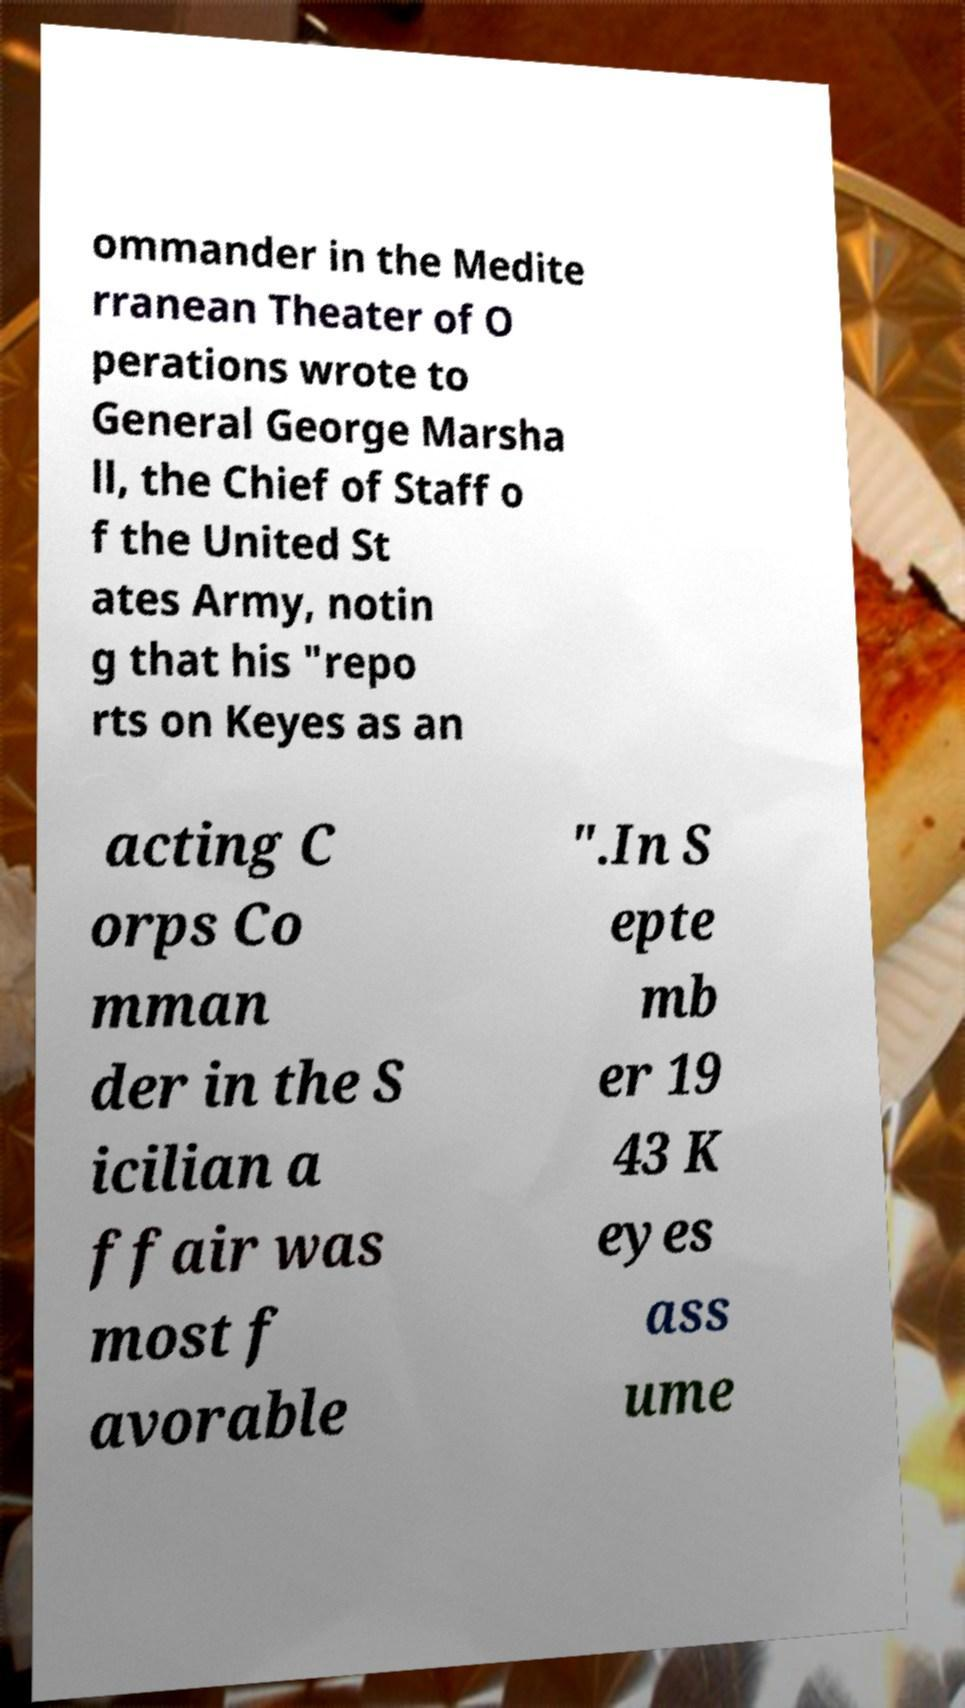Please read and relay the text visible in this image. What does it say? ommander in the Medite rranean Theater of O perations wrote to General George Marsha ll, the Chief of Staff o f the United St ates Army, notin g that his "repo rts on Keyes as an acting C orps Co mman der in the S icilian a ffair was most f avorable ".In S epte mb er 19 43 K eyes ass ume 